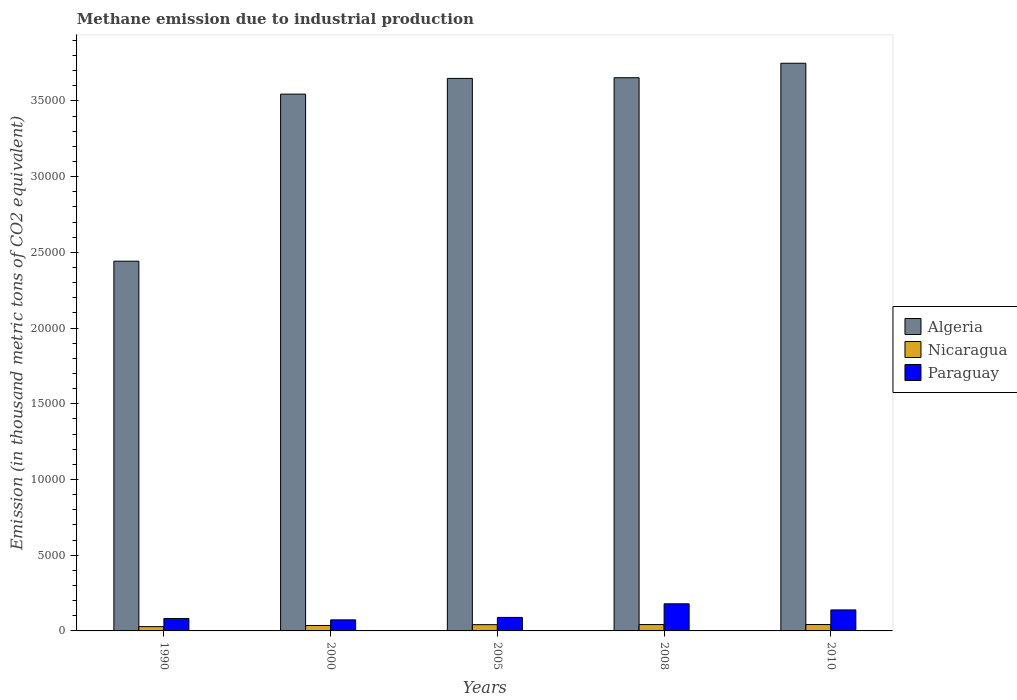How many different coloured bars are there?
Your answer should be very brief. 3. Are the number of bars per tick equal to the number of legend labels?
Offer a terse response. Yes. How many bars are there on the 5th tick from the right?
Keep it short and to the point. 3. What is the label of the 5th group of bars from the left?
Offer a very short reply. 2010. What is the amount of methane emitted in Nicaragua in 2010?
Keep it short and to the point. 422.1. Across all years, what is the maximum amount of methane emitted in Nicaragua?
Offer a very short reply. 422.1. Across all years, what is the minimum amount of methane emitted in Algeria?
Provide a succinct answer. 2.44e+04. In which year was the amount of methane emitted in Nicaragua maximum?
Offer a very short reply. 2010. What is the total amount of methane emitted in Paraguay in the graph?
Make the answer very short. 5620.6. What is the difference between the amount of methane emitted in Paraguay in 1990 and that in 2008?
Provide a short and direct response. -969.1. What is the difference between the amount of methane emitted in Paraguay in 2008 and the amount of methane emitted in Algeria in 2000?
Ensure brevity in your answer.  -3.37e+04. What is the average amount of methane emitted in Algeria per year?
Offer a terse response. 3.41e+04. In the year 1990, what is the difference between the amount of methane emitted in Algeria and amount of methane emitted in Paraguay?
Give a very brief answer. 2.36e+04. What is the ratio of the amount of methane emitted in Algeria in 1990 to that in 2000?
Your response must be concise. 0.69. Is the amount of methane emitted in Paraguay in 2000 less than that in 2010?
Offer a terse response. Yes. What is the difference between the highest and the second highest amount of methane emitted in Nicaragua?
Offer a terse response. 1.4. What is the difference between the highest and the lowest amount of methane emitted in Nicaragua?
Provide a succinct answer. 138. In how many years, is the amount of methane emitted in Paraguay greater than the average amount of methane emitted in Paraguay taken over all years?
Keep it short and to the point. 2. What does the 3rd bar from the left in 2000 represents?
Your response must be concise. Paraguay. What does the 3rd bar from the right in 2008 represents?
Your response must be concise. Algeria. Is it the case that in every year, the sum of the amount of methane emitted in Nicaragua and amount of methane emitted in Algeria is greater than the amount of methane emitted in Paraguay?
Provide a short and direct response. Yes. How many bars are there?
Offer a terse response. 15. Are all the bars in the graph horizontal?
Offer a terse response. No. How many years are there in the graph?
Keep it short and to the point. 5. What is the difference between two consecutive major ticks on the Y-axis?
Make the answer very short. 5000. Where does the legend appear in the graph?
Keep it short and to the point. Center right. How many legend labels are there?
Provide a succinct answer. 3. What is the title of the graph?
Your answer should be compact. Methane emission due to industrial production. Does "Estonia" appear as one of the legend labels in the graph?
Give a very brief answer. No. What is the label or title of the X-axis?
Make the answer very short. Years. What is the label or title of the Y-axis?
Provide a short and direct response. Emission (in thousand metric tons of CO2 equivalent). What is the Emission (in thousand metric tons of CO2 equivalent) in Algeria in 1990?
Give a very brief answer. 2.44e+04. What is the Emission (in thousand metric tons of CO2 equivalent) of Nicaragua in 1990?
Offer a terse response. 284.1. What is the Emission (in thousand metric tons of CO2 equivalent) of Paraguay in 1990?
Ensure brevity in your answer.  821.6. What is the Emission (in thousand metric tons of CO2 equivalent) of Algeria in 2000?
Your answer should be very brief. 3.54e+04. What is the Emission (in thousand metric tons of CO2 equivalent) in Nicaragua in 2000?
Provide a succinct answer. 359.5. What is the Emission (in thousand metric tons of CO2 equivalent) of Paraguay in 2000?
Keep it short and to the point. 730.2. What is the Emission (in thousand metric tons of CO2 equivalent) of Algeria in 2005?
Offer a terse response. 3.65e+04. What is the Emission (in thousand metric tons of CO2 equivalent) in Nicaragua in 2005?
Give a very brief answer. 412.7. What is the Emission (in thousand metric tons of CO2 equivalent) of Paraguay in 2005?
Your answer should be very brief. 891.9. What is the Emission (in thousand metric tons of CO2 equivalent) in Algeria in 2008?
Offer a very short reply. 3.65e+04. What is the Emission (in thousand metric tons of CO2 equivalent) of Nicaragua in 2008?
Keep it short and to the point. 420.7. What is the Emission (in thousand metric tons of CO2 equivalent) of Paraguay in 2008?
Provide a short and direct response. 1790.7. What is the Emission (in thousand metric tons of CO2 equivalent) of Algeria in 2010?
Keep it short and to the point. 3.75e+04. What is the Emission (in thousand metric tons of CO2 equivalent) in Nicaragua in 2010?
Offer a very short reply. 422.1. What is the Emission (in thousand metric tons of CO2 equivalent) of Paraguay in 2010?
Keep it short and to the point. 1386.2. Across all years, what is the maximum Emission (in thousand metric tons of CO2 equivalent) of Algeria?
Provide a short and direct response. 3.75e+04. Across all years, what is the maximum Emission (in thousand metric tons of CO2 equivalent) of Nicaragua?
Provide a short and direct response. 422.1. Across all years, what is the maximum Emission (in thousand metric tons of CO2 equivalent) in Paraguay?
Provide a short and direct response. 1790.7. Across all years, what is the minimum Emission (in thousand metric tons of CO2 equivalent) in Algeria?
Your answer should be compact. 2.44e+04. Across all years, what is the minimum Emission (in thousand metric tons of CO2 equivalent) in Nicaragua?
Offer a terse response. 284.1. Across all years, what is the minimum Emission (in thousand metric tons of CO2 equivalent) in Paraguay?
Keep it short and to the point. 730.2. What is the total Emission (in thousand metric tons of CO2 equivalent) in Algeria in the graph?
Keep it short and to the point. 1.70e+05. What is the total Emission (in thousand metric tons of CO2 equivalent) in Nicaragua in the graph?
Your answer should be compact. 1899.1. What is the total Emission (in thousand metric tons of CO2 equivalent) of Paraguay in the graph?
Your answer should be very brief. 5620.6. What is the difference between the Emission (in thousand metric tons of CO2 equivalent) of Algeria in 1990 and that in 2000?
Ensure brevity in your answer.  -1.10e+04. What is the difference between the Emission (in thousand metric tons of CO2 equivalent) in Nicaragua in 1990 and that in 2000?
Your response must be concise. -75.4. What is the difference between the Emission (in thousand metric tons of CO2 equivalent) in Paraguay in 1990 and that in 2000?
Give a very brief answer. 91.4. What is the difference between the Emission (in thousand metric tons of CO2 equivalent) of Algeria in 1990 and that in 2005?
Provide a short and direct response. -1.21e+04. What is the difference between the Emission (in thousand metric tons of CO2 equivalent) of Nicaragua in 1990 and that in 2005?
Your answer should be very brief. -128.6. What is the difference between the Emission (in thousand metric tons of CO2 equivalent) of Paraguay in 1990 and that in 2005?
Offer a terse response. -70.3. What is the difference between the Emission (in thousand metric tons of CO2 equivalent) in Algeria in 1990 and that in 2008?
Give a very brief answer. -1.21e+04. What is the difference between the Emission (in thousand metric tons of CO2 equivalent) of Nicaragua in 1990 and that in 2008?
Offer a terse response. -136.6. What is the difference between the Emission (in thousand metric tons of CO2 equivalent) in Paraguay in 1990 and that in 2008?
Your answer should be very brief. -969.1. What is the difference between the Emission (in thousand metric tons of CO2 equivalent) of Algeria in 1990 and that in 2010?
Your answer should be very brief. -1.31e+04. What is the difference between the Emission (in thousand metric tons of CO2 equivalent) of Nicaragua in 1990 and that in 2010?
Make the answer very short. -138. What is the difference between the Emission (in thousand metric tons of CO2 equivalent) of Paraguay in 1990 and that in 2010?
Your answer should be compact. -564.6. What is the difference between the Emission (in thousand metric tons of CO2 equivalent) of Algeria in 2000 and that in 2005?
Your answer should be very brief. -1037.5. What is the difference between the Emission (in thousand metric tons of CO2 equivalent) of Nicaragua in 2000 and that in 2005?
Your answer should be compact. -53.2. What is the difference between the Emission (in thousand metric tons of CO2 equivalent) in Paraguay in 2000 and that in 2005?
Your answer should be very brief. -161.7. What is the difference between the Emission (in thousand metric tons of CO2 equivalent) in Algeria in 2000 and that in 2008?
Keep it short and to the point. -1082.4. What is the difference between the Emission (in thousand metric tons of CO2 equivalent) in Nicaragua in 2000 and that in 2008?
Give a very brief answer. -61.2. What is the difference between the Emission (in thousand metric tons of CO2 equivalent) in Paraguay in 2000 and that in 2008?
Your response must be concise. -1060.5. What is the difference between the Emission (in thousand metric tons of CO2 equivalent) of Algeria in 2000 and that in 2010?
Your answer should be very brief. -2037.3. What is the difference between the Emission (in thousand metric tons of CO2 equivalent) in Nicaragua in 2000 and that in 2010?
Offer a terse response. -62.6. What is the difference between the Emission (in thousand metric tons of CO2 equivalent) in Paraguay in 2000 and that in 2010?
Your response must be concise. -656. What is the difference between the Emission (in thousand metric tons of CO2 equivalent) of Algeria in 2005 and that in 2008?
Provide a short and direct response. -44.9. What is the difference between the Emission (in thousand metric tons of CO2 equivalent) of Paraguay in 2005 and that in 2008?
Ensure brevity in your answer.  -898.8. What is the difference between the Emission (in thousand metric tons of CO2 equivalent) of Algeria in 2005 and that in 2010?
Give a very brief answer. -999.8. What is the difference between the Emission (in thousand metric tons of CO2 equivalent) of Paraguay in 2005 and that in 2010?
Ensure brevity in your answer.  -494.3. What is the difference between the Emission (in thousand metric tons of CO2 equivalent) of Algeria in 2008 and that in 2010?
Give a very brief answer. -954.9. What is the difference between the Emission (in thousand metric tons of CO2 equivalent) of Paraguay in 2008 and that in 2010?
Your response must be concise. 404.5. What is the difference between the Emission (in thousand metric tons of CO2 equivalent) in Algeria in 1990 and the Emission (in thousand metric tons of CO2 equivalent) in Nicaragua in 2000?
Make the answer very short. 2.41e+04. What is the difference between the Emission (in thousand metric tons of CO2 equivalent) of Algeria in 1990 and the Emission (in thousand metric tons of CO2 equivalent) of Paraguay in 2000?
Your answer should be very brief. 2.37e+04. What is the difference between the Emission (in thousand metric tons of CO2 equivalent) of Nicaragua in 1990 and the Emission (in thousand metric tons of CO2 equivalent) of Paraguay in 2000?
Ensure brevity in your answer.  -446.1. What is the difference between the Emission (in thousand metric tons of CO2 equivalent) in Algeria in 1990 and the Emission (in thousand metric tons of CO2 equivalent) in Nicaragua in 2005?
Keep it short and to the point. 2.40e+04. What is the difference between the Emission (in thousand metric tons of CO2 equivalent) in Algeria in 1990 and the Emission (in thousand metric tons of CO2 equivalent) in Paraguay in 2005?
Your response must be concise. 2.35e+04. What is the difference between the Emission (in thousand metric tons of CO2 equivalent) of Nicaragua in 1990 and the Emission (in thousand metric tons of CO2 equivalent) of Paraguay in 2005?
Offer a terse response. -607.8. What is the difference between the Emission (in thousand metric tons of CO2 equivalent) of Algeria in 1990 and the Emission (in thousand metric tons of CO2 equivalent) of Nicaragua in 2008?
Offer a terse response. 2.40e+04. What is the difference between the Emission (in thousand metric tons of CO2 equivalent) in Algeria in 1990 and the Emission (in thousand metric tons of CO2 equivalent) in Paraguay in 2008?
Your answer should be compact. 2.26e+04. What is the difference between the Emission (in thousand metric tons of CO2 equivalent) of Nicaragua in 1990 and the Emission (in thousand metric tons of CO2 equivalent) of Paraguay in 2008?
Keep it short and to the point. -1506.6. What is the difference between the Emission (in thousand metric tons of CO2 equivalent) in Algeria in 1990 and the Emission (in thousand metric tons of CO2 equivalent) in Nicaragua in 2010?
Provide a succinct answer. 2.40e+04. What is the difference between the Emission (in thousand metric tons of CO2 equivalent) of Algeria in 1990 and the Emission (in thousand metric tons of CO2 equivalent) of Paraguay in 2010?
Ensure brevity in your answer.  2.30e+04. What is the difference between the Emission (in thousand metric tons of CO2 equivalent) in Nicaragua in 1990 and the Emission (in thousand metric tons of CO2 equivalent) in Paraguay in 2010?
Make the answer very short. -1102.1. What is the difference between the Emission (in thousand metric tons of CO2 equivalent) in Algeria in 2000 and the Emission (in thousand metric tons of CO2 equivalent) in Nicaragua in 2005?
Your answer should be very brief. 3.50e+04. What is the difference between the Emission (in thousand metric tons of CO2 equivalent) of Algeria in 2000 and the Emission (in thousand metric tons of CO2 equivalent) of Paraguay in 2005?
Your answer should be very brief. 3.46e+04. What is the difference between the Emission (in thousand metric tons of CO2 equivalent) of Nicaragua in 2000 and the Emission (in thousand metric tons of CO2 equivalent) of Paraguay in 2005?
Make the answer very short. -532.4. What is the difference between the Emission (in thousand metric tons of CO2 equivalent) in Algeria in 2000 and the Emission (in thousand metric tons of CO2 equivalent) in Nicaragua in 2008?
Offer a very short reply. 3.50e+04. What is the difference between the Emission (in thousand metric tons of CO2 equivalent) of Algeria in 2000 and the Emission (in thousand metric tons of CO2 equivalent) of Paraguay in 2008?
Keep it short and to the point. 3.37e+04. What is the difference between the Emission (in thousand metric tons of CO2 equivalent) of Nicaragua in 2000 and the Emission (in thousand metric tons of CO2 equivalent) of Paraguay in 2008?
Provide a short and direct response. -1431.2. What is the difference between the Emission (in thousand metric tons of CO2 equivalent) of Algeria in 2000 and the Emission (in thousand metric tons of CO2 equivalent) of Nicaragua in 2010?
Provide a succinct answer. 3.50e+04. What is the difference between the Emission (in thousand metric tons of CO2 equivalent) of Algeria in 2000 and the Emission (in thousand metric tons of CO2 equivalent) of Paraguay in 2010?
Give a very brief answer. 3.41e+04. What is the difference between the Emission (in thousand metric tons of CO2 equivalent) in Nicaragua in 2000 and the Emission (in thousand metric tons of CO2 equivalent) in Paraguay in 2010?
Your answer should be very brief. -1026.7. What is the difference between the Emission (in thousand metric tons of CO2 equivalent) in Algeria in 2005 and the Emission (in thousand metric tons of CO2 equivalent) in Nicaragua in 2008?
Keep it short and to the point. 3.61e+04. What is the difference between the Emission (in thousand metric tons of CO2 equivalent) of Algeria in 2005 and the Emission (in thousand metric tons of CO2 equivalent) of Paraguay in 2008?
Your response must be concise. 3.47e+04. What is the difference between the Emission (in thousand metric tons of CO2 equivalent) in Nicaragua in 2005 and the Emission (in thousand metric tons of CO2 equivalent) in Paraguay in 2008?
Offer a very short reply. -1378. What is the difference between the Emission (in thousand metric tons of CO2 equivalent) of Algeria in 2005 and the Emission (in thousand metric tons of CO2 equivalent) of Nicaragua in 2010?
Your response must be concise. 3.61e+04. What is the difference between the Emission (in thousand metric tons of CO2 equivalent) of Algeria in 2005 and the Emission (in thousand metric tons of CO2 equivalent) of Paraguay in 2010?
Provide a succinct answer. 3.51e+04. What is the difference between the Emission (in thousand metric tons of CO2 equivalent) of Nicaragua in 2005 and the Emission (in thousand metric tons of CO2 equivalent) of Paraguay in 2010?
Provide a succinct answer. -973.5. What is the difference between the Emission (in thousand metric tons of CO2 equivalent) in Algeria in 2008 and the Emission (in thousand metric tons of CO2 equivalent) in Nicaragua in 2010?
Keep it short and to the point. 3.61e+04. What is the difference between the Emission (in thousand metric tons of CO2 equivalent) in Algeria in 2008 and the Emission (in thousand metric tons of CO2 equivalent) in Paraguay in 2010?
Your answer should be very brief. 3.51e+04. What is the difference between the Emission (in thousand metric tons of CO2 equivalent) in Nicaragua in 2008 and the Emission (in thousand metric tons of CO2 equivalent) in Paraguay in 2010?
Offer a terse response. -965.5. What is the average Emission (in thousand metric tons of CO2 equivalent) of Algeria per year?
Offer a very short reply. 3.41e+04. What is the average Emission (in thousand metric tons of CO2 equivalent) of Nicaragua per year?
Your answer should be compact. 379.82. What is the average Emission (in thousand metric tons of CO2 equivalent) in Paraguay per year?
Ensure brevity in your answer.  1124.12. In the year 1990, what is the difference between the Emission (in thousand metric tons of CO2 equivalent) in Algeria and Emission (in thousand metric tons of CO2 equivalent) in Nicaragua?
Offer a terse response. 2.41e+04. In the year 1990, what is the difference between the Emission (in thousand metric tons of CO2 equivalent) in Algeria and Emission (in thousand metric tons of CO2 equivalent) in Paraguay?
Provide a short and direct response. 2.36e+04. In the year 1990, what is the difference between the Emission (in thousand metric tons of CO2 equivalent) in Nicaragua and Emission (in thousand metric tons of CO2 equivalent) in Paraguay?
Ensure brevity in your answer.  -537.5. In the year 2000, what is the difference between the Emission (in thousand metric tons of CO2 equivalent) of Algeria and Emission (in thousand metric tons of CO2 equivalent) of Nicaragua?
Make the answer very short. 3.51e+04. In the year 2000, what is the difference between the Emission (in thousand metric tons of CO2 equivalent) of Algeria and Emission (in thousand metric tons of CO2 equivalent) of Paraguay?
Ensure brevity in your answer.  3.47e+04. In the year 2000, what is the difference between the Emission (in thousand metric tons of CO2 equivalent) of Nicaragua and Emission (in thousand metric tons of CO2 equivalent) of Paraguay?
Offer a terse response. -370.7. In the year 2005, what is the difference between the Emission (in thousand metric tons of CO2 equivalent) of Algeria and Emission (in thousand metric tons of CO2 equivalent) of Nicaragua?
Keep it short and to the point. 3.61e+04. In the year 2005, what is the difference between the Emission (in thousand metric tons of CO2 equivalent) of Algeria and Emission (in thousand metric tons of CO2 equivalent) of Paraguay?
Offer a very short reply. 3.56e+04. In the year 2005, what is the difference between the Emission (in thousand metric tons of CO2 equivalent) in Nicaragua and Emission (in thousand metric tons of CO2 equivalent) in Paraguay?
Keep it short and to the point. -479.2. In the year 2008, what is the difference between the Emission (in thousand metric tons of CO2 equivalent) of Algeria and Emission (in thousand metric tons of CO2 equivalent) of Nicaragua?
Your answer should be very brief. 3.61e+04. In the year 2008, what is the difference between the Emission (in thousand metric tons of CO2 equivalent) of Algeria and Emission (in thousand metric tons of CO2 equivalent) of Paraguay?
Your response must be concise. 3.47e+04. In the year 2008, what is the difference between the Emission (in thousand metric tons of CO2 equivalent) in Nicaragua and Emission (in thousand metric tons of CO2 equivalent) in Paraguay?
Your answer should be very brief. -1370. In the year 2010, what is the difference between the Emission (in thousand metric tons of CO2 equivalent) in Algeria and Emission (in thousand metric tons of CO2 equivalent) in Nicaragua?
Your answer should be compact. 3.71e+04. In the year 2010, what is the difference between the Emission (in thousand metric tons of CO2 equivalent) of Algeria and Emission (in thousand metric tons of CO2 equivalent) of Paraguay?
Provide a short and direct response. 3.61e+04. In the year 2010, what is the difference between the Emission (in thousand metric tons of CO2 equivalent) in Nicaragua and Emission (in thousand metric tons of CO2 equivalent) in Paraguay?
Your answer should be compact. -964.1. What is the ratio of the Emission (in thousand metric tons of CO2 equivalent) in Algeria in 1990 to that in 2000?
Your answer should be compact. 0.69. What is the ratio of the Emission (in thousand metric tons of CO2 equivalent) of Nicaragua in 1990 to that in 2000?
Your answer should be compact. 0.79. What is the ratio of the Emission (in thousand metric tons of CO2 equivalent) of Paraguay in 1990 to that in 2000?
Offer a terse response. 1.13. What is the ratio of the Emission (in thousand metric tons of CO2 equivalent) in Algeria in 1990 to that in 2005?
Your answer should be very brief. 0.67. What is the ratio of the Emission (in thousand metric tons of CO2 equivalent) of Nicaragua in 1990 to that in 2005?
Your answer should be compact. 0.69. What is the ratio of the Emission (in thousand metric tons of CO2 equivalent) of Paraguay in 1990 to that in 2005?
Provide a succinct answer. 0.92. What is the ratio of the Emission (in thousand metric tons of CO2 equivalent) in Algeria in 1990 to that in 2008?
Your answer should be compact. 0.67. What is the ratio of the Emission (in thousand metric tons of CO2 equivalent) in Nicaragua in 1990 to that in 2008?
Your answer should be compact. 0.68. What is the ratio of the Emission (in thousand metric tons of CO2 equivalent) in Paraguay in 1990 to that in 2008?
Offer a very short reply. 0.46. What is the ratio of the Emission (in thousand metric tons of CO2 equivalent) in Algeria in 1990 to that in 2010?
Your answer should be very brief. 0.65. What is the ratio of the Emission (in thousand metric tons of CO2 equivalent) in Nicaragua in 1990 to that in 2010?
Your response must be concise. 0.67. What is the ratio of the Emission (in thousand metric tons of CO2 equivalent) in Paraguay in 1990 to that in 2010?
Your answer should be very brief. 0.59. What is the ratio of the Emission (in thousand metric tons of CO2 equivalent) of Algeria in 2000 to that in 2005?
Ensure brevity in your answer.  0.97. What is the ratio of the Emission (in thousand metric tons of CO2 equivalent) of Nicaragua in 2000 to that in 2005?
Ensure brevity in your answer.  0.87. What is the ratio of the Emission (in thousand metric tons of CO2 equivalent) in Paraguay in 2000 to that in 2005?
Your answer should be compact. 0.82. What is the ratio of the Emission (in thousand metric tons of CO2 equivalent) in Algeria in 2000 to that in 2008?
Offer a very short reply. 0.97. What is the ratio of the Emission (in thousand metric tons of CO2 equivalent) of Nicaragua in 2000 to that in 2008?
Your answer should be very brief. 0.85. What is the ratio of the Emission (in thousand metric tons of CO2 equivalent) of Paraguay in 2000 to that in 2008?
Offer a very short reply. 0.41. What is the ratio of the Emission (in thousand metric tons of CO2 equivalent) of Algeria in 2000 to that in 2010?
Ensure brevity in your answer.  0.95. What is the ratio of the Emission (in thousand metric tons of CO2 equivalent) of Nicaragua in 2000 to that in 2010?
Your response must be concise. 0.85. What is the ratio of the Emission (in thousand metric tons of CO2 equivalent) in Paraguay in 2000 to that in 2010?
Offer a terse response. 0.53. What is the ratio of the Emission (in thousand metric tons of CO2 equivalent) in Nicaragua in 2005 to that in 2008?
Your answer should be very brief. 0.98. What is the ratio of the Emission (in thousand metric tons of CO2 equivalent) of Paraguay in 2005 to that in 2008?
Provide a short and direct response. 0.5. What is the ratio of the Emission (in thousand metric tons of CO2 equivalent) of Algeria in 2005 to that in 2010?
Give a very brief answer. 0.97. What is the ratio of the Emission (in thousand metric tons of CO2 equivalent) of Nicaragua in 2005 to that in 2010?
Your answer should be very brief. 0.98. What is the ratio of the Emission (in thousand metric tons of CO2 equivalent) of Paraguay in 2005 to that in 2010?
Give a very brief answer. 0.64. What is the ratio of the Emission (in thousand metric tons of CO2 equivalent) of Algeria in 2008 to that in 2010?
Provide a short and direct response. 0.97. What is the ratio of the Emission (in thousand metric tons of CO2 equivalent) of Paraguay in 2008 to that in 2010?
Offer a terse response. 1.29. What is the difference between the highest and the second highest Emission (in thousand metric tons of CO2 equivalent) of Algeria?
Keep it short and to the point. 954.9. What is the difference between the highest and the second highest Emission (in thousand metric tons of CO2 equivalent) in Paraguay?
Provide a short and direct response. 404.5. What is the difference between the highest and the lowest Emission (in thousand metric tons of CO2 equivalent) of Algeria?
Offer a terse response. 1.31e+04. What is the difference between the highest and the lowest Emission (in thousand metric tons of CO2 equivalent) of Nicaragua?
Provide a succinct answer. 138. What is the difference between the highest and the lowest Emission (in thousand metric tons of CO2 equivalent) in Paraguay?
Your answer should be very brief. 1060.5. 